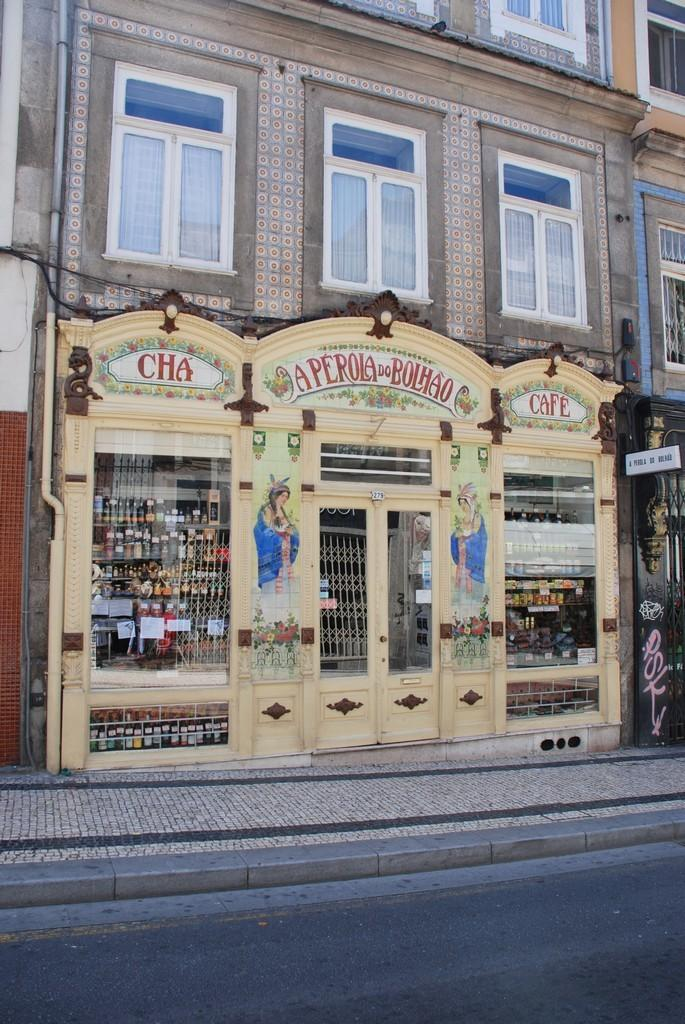What type of structure is present in the image? There is a building in the image. What can be found inside the building? There is a store in the building. How can one enter the building? There is a door in the building. What allows natural light to enter the building? There are windows in the building. What can be seen from the windows? Groceries are visible from the windows. What type of map is hanging on the wall inside the store? There is no map visible in the image; it only shows the building's exterior. What unit of measurement is used to determine the size of the fruit in the store? There is no fruit present in the image, so it is not possible to determine the unit of measurement used. 